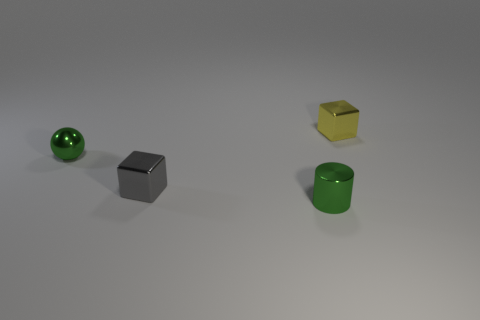Add 1 tiny green metallic cylinders. How many objects exist? 5 Subtract all cylinders. How many objects are left? 3 Subtract all cyan rubber blocks. Subtract all small things. How many objects are left? 0 Add 2 cylinders. How many cylinders are left? 3 Add 4 balls. How many balls exist? 5 Subtract 0 blue blocks. How many objects are left? 4 